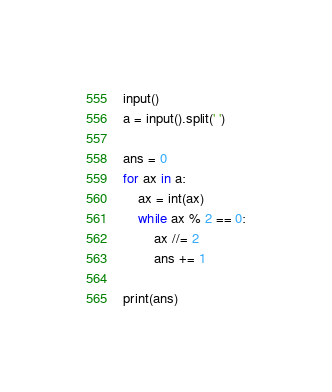Convert code to text. <code><loc_0><loc_0><loc_500><loc_500><_Python_>input()
a = input().split(' ')

ans = 0
for ax in a:
    ax = int(ax)
    while ax % 2 == 0:
        ax //= 2
        ans += 1

print(ans)
</code> 